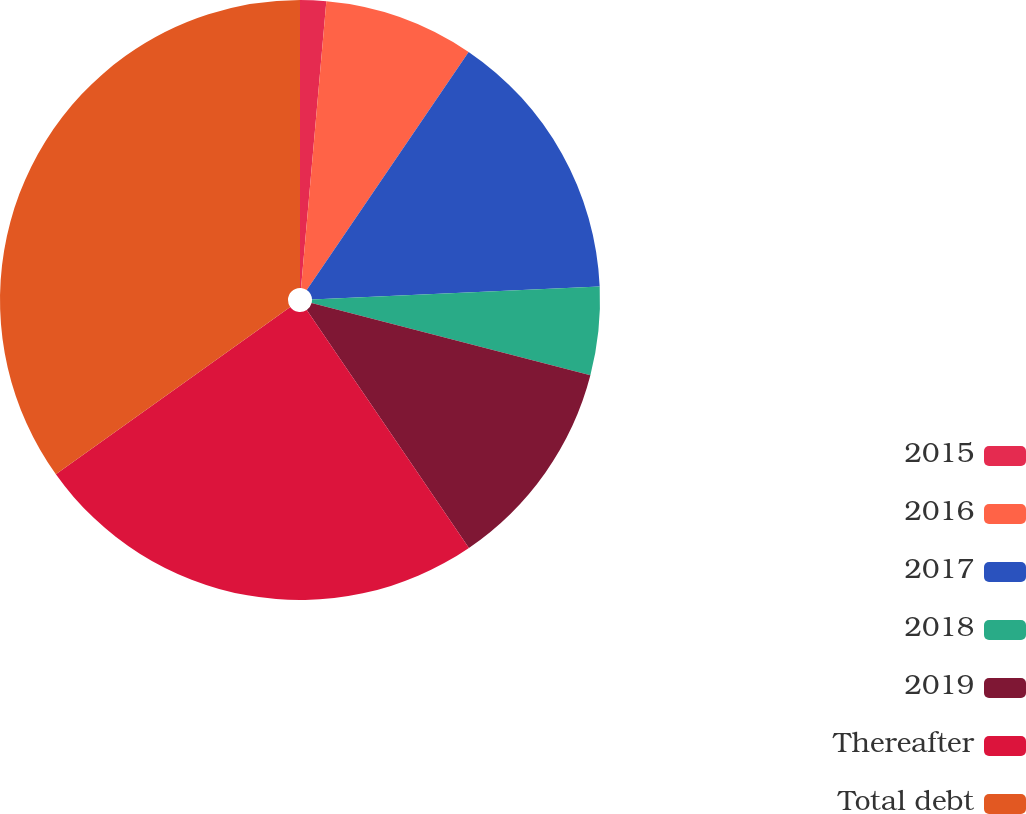Convert chart. <chart><loc_0><loc_0><loc_500><loc_500><pie_chart><fcel>2015<fcel>2016<fcel>2017<fcel>2018<fcel>2019<fcel>Thereafter<fcel>Total debt<nl><fcel>1.4%<fcel>8.1%<fcel>14.79%<fcel>4.75%<fcel>11.44%<fcel>24.65%<fcel>34.87%<nl></chart> 